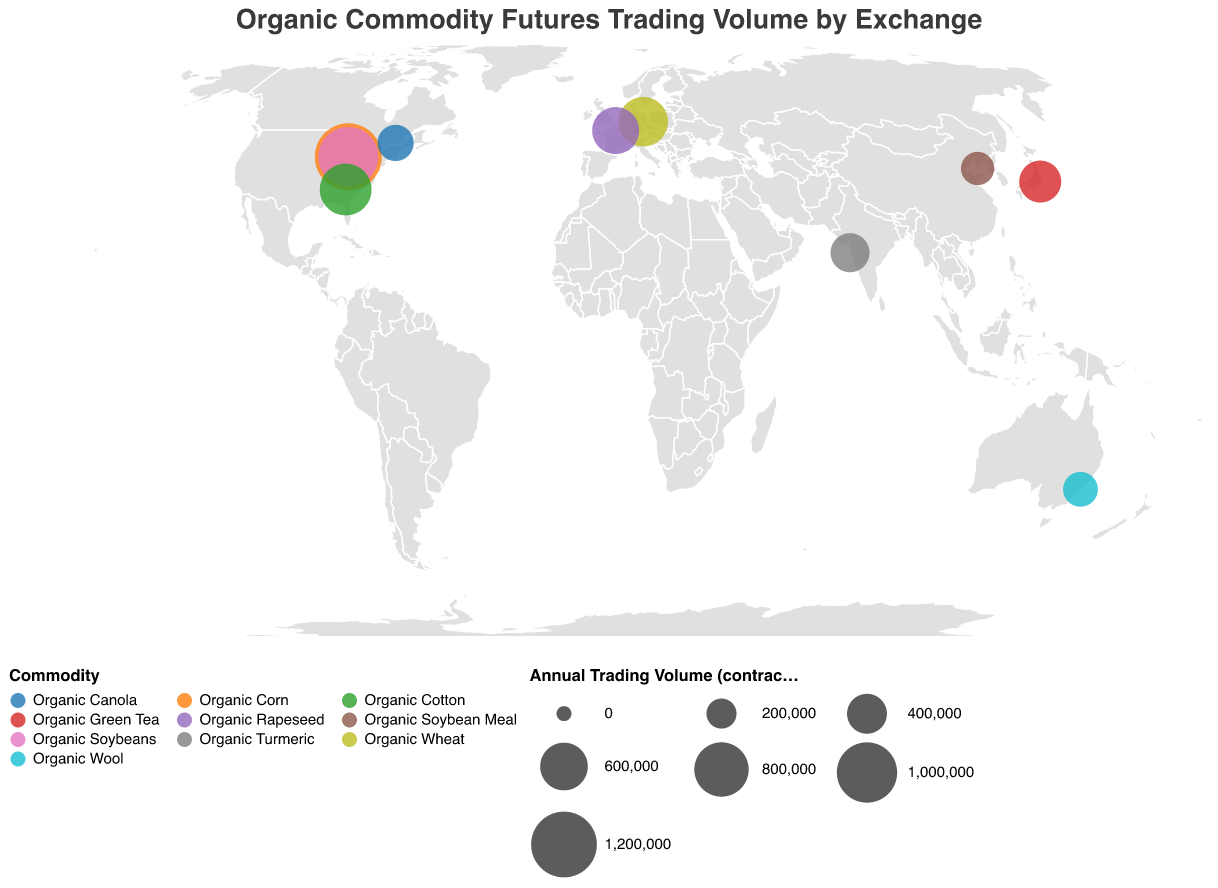How many major agricultural exchanges are represented in the plot? By counting the unique values in the "Exchange" field represented by different locations across the globe, we can determine the number of distinct agricultural exchanges.
Answer: 10 Which exchange has the highest annual trading volume for a single commodity, and what is that volume? Identify the largest circle representing the highest annual trading volume, which corresponds to the Chicago Mercantile Exchange in the USA for Organic Corn with a volume of 1,250,000 contracts.
Answer: Chicago Mercantile Exchange, 1,250,000 contracts What is the total annual trading volume for all commodities traded in the United States according to the figure? Sum the trading volumes for all commodities listed under the USA. For Organic Corn (1,250,000) + Organic Soybeans (980,000) + Organic Cotton (720,000) = 2,950,000 contracts.
Answer: 2,950,000 contracts Which commodity traded in Asia has the highest trading volume and what is the exchange? Locate the data points in Asia (Japan, India, and China) and compare their trading volumes. Organic Green Tea traded at the Tokyo Commodity Exchange has the highest volume at 450,000 contracts.
Answer: Organic Green Tea, Tokyo Commodity Exchange How does the trading volume of Organic Turmeric in India compare to that of Organic Green Tea in Japan? Look at the circle sizes and volumes: Organic Turmeric at 380,000 contracts in India and Organic Green Tea at 450,000 contracts in Japan. The Turkish volume is lower.
Answer: Lower What is the combined trading volume for commodities traded in Europe (Germany and France)? Sum the trading volumes for Organic Wheat in Germany (650,000) and Organic Rapeseed in France (580,000) for a total of 1,230,000 contracts.
Answer: 1,230,000 contracts Which continent has the widest variety of organic commodities being traded, and what are they? Examine the diversity of commodities across each continent. North America (USA and Canada) has Organic Corn, Soybeans, Cotton, and Canola, totaling four different commodities.
Answer: North America, 4 commodities Is there a geographic pattern observed in the trading volumes for different organic commodities worldwide? By observing the circle sizes on the plot, it is noticeable that North America (particularly the USA) has larger trading volumes compared to other regions, indicating a potentially higher demand or supply region for organic commodities.
Answer: North America has larger trading volumes Which commodity has the least trading volume and where is it traded? Identify the smallest circle on the plot corresponding to the lowest volume. Organic Soybean Meal in China has the smallest volume at 260,000 contracts.
Answer: Organic Soybean Meal, China Compare the trading volumes of Organic Wheat in Europe to Organic Canola in Canada. Which has a larger volume? Look at the figures for Organic Wheat in Germany (650,000 contracts) and Organic Canola in Canada (320,000 contracts); Wheat has a substantially larger trading volume.
Answer: Organic Wheat in Europe 